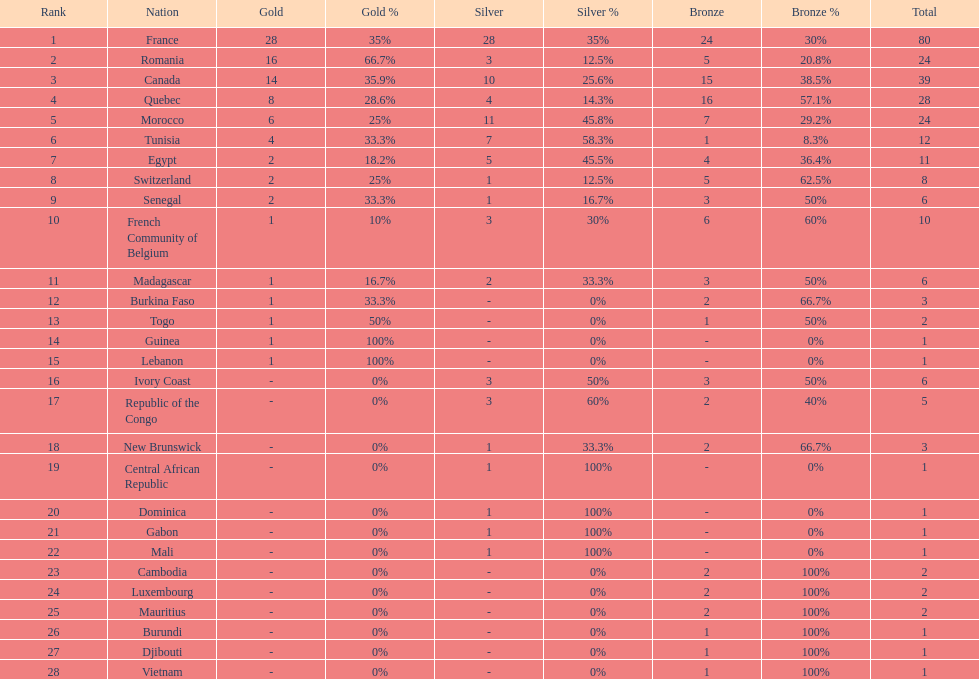How many more medals did egypt win than ivory coast? 5. 